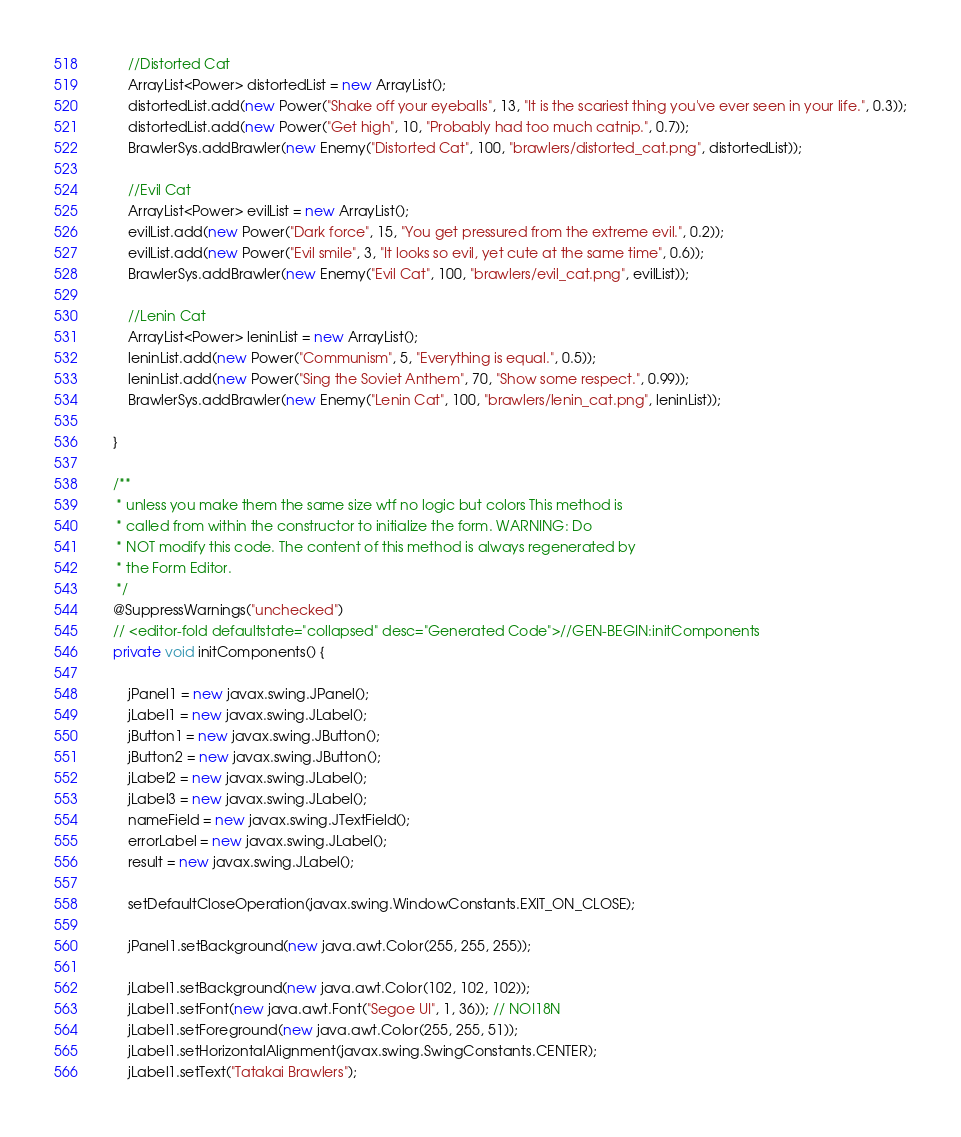<code> <loc_0><loc_0><loc_500><loc_500><_Java_>
        //Distorted Cat
        ArrayList<Power> distortedList = new ArrayList();
        distortedList.add(new Power("Shake off your eyeballs", 13, "It is the scariest thing you've ever seen in your life.", 0.3));
        distortedList.add(new Power("Get high", 10, "Probably had too much catnip.", 0.7));
        BrawlerSys.addBrawler(new Enemy("Distorted Cat", 100, "brawlers/distorted_cat.png", distortedList));

        //Evil Cat
        ArrayList<Power> evilList = new ArrayList();
        evilList.add(new Power("Dark force", 15, "You get pressured from the extreme evil.", 0.2));
        evilList.add(new Power("Evil smile", 3, "It looks so evil, yet cute at the same time", 0.6));
        BrawlerSys.addBrawler(new Enemy("Evil Cat", 100, "brawlers/evil_cat.png", evilList));

        //Lenin Cat
        ArrayList<Power> leninList = new ArrayList();
        leninList.add(new Power("Communism", 5, "Everything is equal.", 0.5));
        leninList.add(new Power("Sing the Soviet Anthem", 70, "Show some respect.", 0.99));
        BrawlerSys.addBrawler(new Enemy("Lenin Cat", 100, "brawlers/lenin_cat.png", leninList));

    }

    /**
     * unless you make them the same size wtf no logic but colors This method is
     * called from within the constructor to initialize the form. WARNING: Do
     * NOT modify this code. The content of this method is always regenerated by
     * the Form Editor.
     */
    @SuppressWarnings("unchecked")
    // <editor-fold defaultstate="collapsed" desc="Generated Code">//GEN-BEGIN:initComponents
    private void initComponents() {

        jPanel1 = new javax.swing.JPanel();
        jLabel1 = new javax.swing.JLabel();
        jButton1 = new javax.swing.JButton();
        jButton2 = new javax.swing.JButton();
        jLabel2 = new javax.swing.JLabel();
        jLabel3 = new javax.swing.JLabel();
        nameField = new javax.swing.JTextField();
        errorLabel = new javax.swing.JLabel();
        result = new javax.swing.JLabel();

        setDefaultCloseOperation(javax.swing.WindowConstants.EXIT_ON_CLOSE);

        jPanel1.setBackground(new java.awt.Color(255, 255, 255));

        jLabel1.setBackground(new java.awt.Color(102, 102, 102));
        jLabel1.setFont(new java.awt.Font("Segoe UI", 1, 36)); // NOI18N
        jLabel1.setForeground(new java.awt.Color(255, 255, 51));
        jLabel1.setHorizontalAlignment(javax.swing.SwingConstants.CENTER);
        jLabel1.setText("Tatakai Brawlers");</code> 